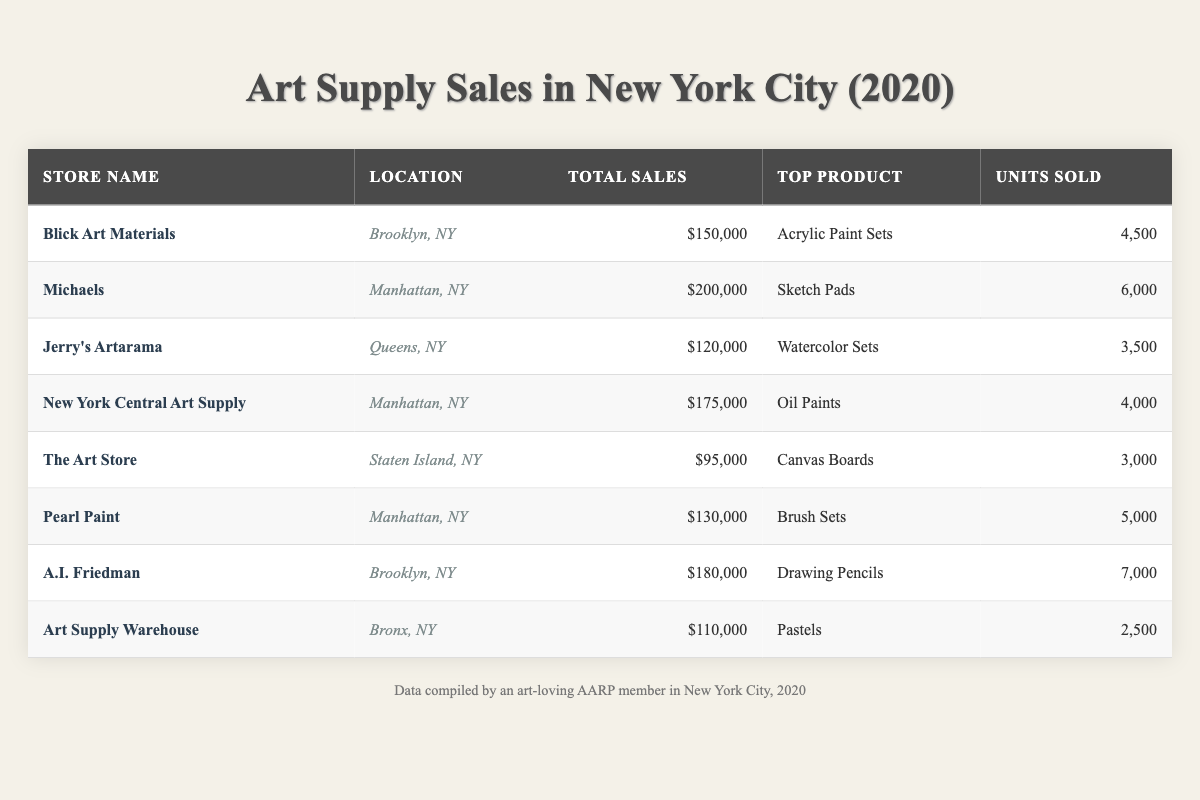What is the top product sold at Michaels? From the table, Michaels has "Sketch Pads" listed as the top product.
Answer: Sketch Pads Which store had the highest total sales? Scanning the total sales figures, Michaels has the highest total sales at $200,000.
Answer: $200,000 How many units of A.I. Friedman sold? A.I. Friedman sold 7,000 units, as shown in the respective row of the table.
Answer: 7,000 What is the total sales figure for stores located in Manhattan? The total sales for stores in Manhattan are calculated by adding Michaels ($200,000), New York Central Art Supply ($175,000), and Pearl Paint ($130,000), resulting in $505,000.
Answer: $505,000 Which products had sales less than $100,000? The products with sales less than $100,000 are from The Art Store with $95,000 and Art Supply Warehouse with $110,000. The Art Store had Canvas Boards.
Answer: The Art Store and Art Supply Warehouse Is the top product sold at Jerry's Artarama Acrylic Paint Sets? The table indicates that Jerry's Artarama's top product is "Watercolor Sets," not Acrylic Paint Sets. Therefore, the statement is false.
Answer: False What is the average total sales across all stores listed in the table? To find the average, sum all total sales: $150,000 + $200,000 + $120,000 + $175,000 + $95,000 + $130,000 + $180,000 + $110,000 = $1,160,000. Divide by 8 (the number of stores) equals $145,000.
Answer: $145,000 How many more units were sold at A.I. Friedman compared to Jerry's Artarama? A.I. Friedman sold 7,000 units and Jerry's Artarama sold 3,500 units. The difference is 7,000 - 3,500 = 3,500.
Answer: 3,500 What percentage of total sales does Pearl Paint represent if the total sales of all stores is $1,160,000? Pearl Paint's total sales are $130,000. To find the percentage: ($130,000 / $1,160,000) * 100 = 11.21%, approximately 11.2%.
Answer: 11.2% Which store had the least total sales, and what was the top product? From the table, The Art Store has the least total sales of $95,000, and its top product is "Canvas Boards."
Answer: The Art Store, Canvas Boards How many units of pastels were sold at Art Supply Warehouse? According to the table, Art Supply Warehouse sold 2,500 units of pastels.
Answer: 2,500 